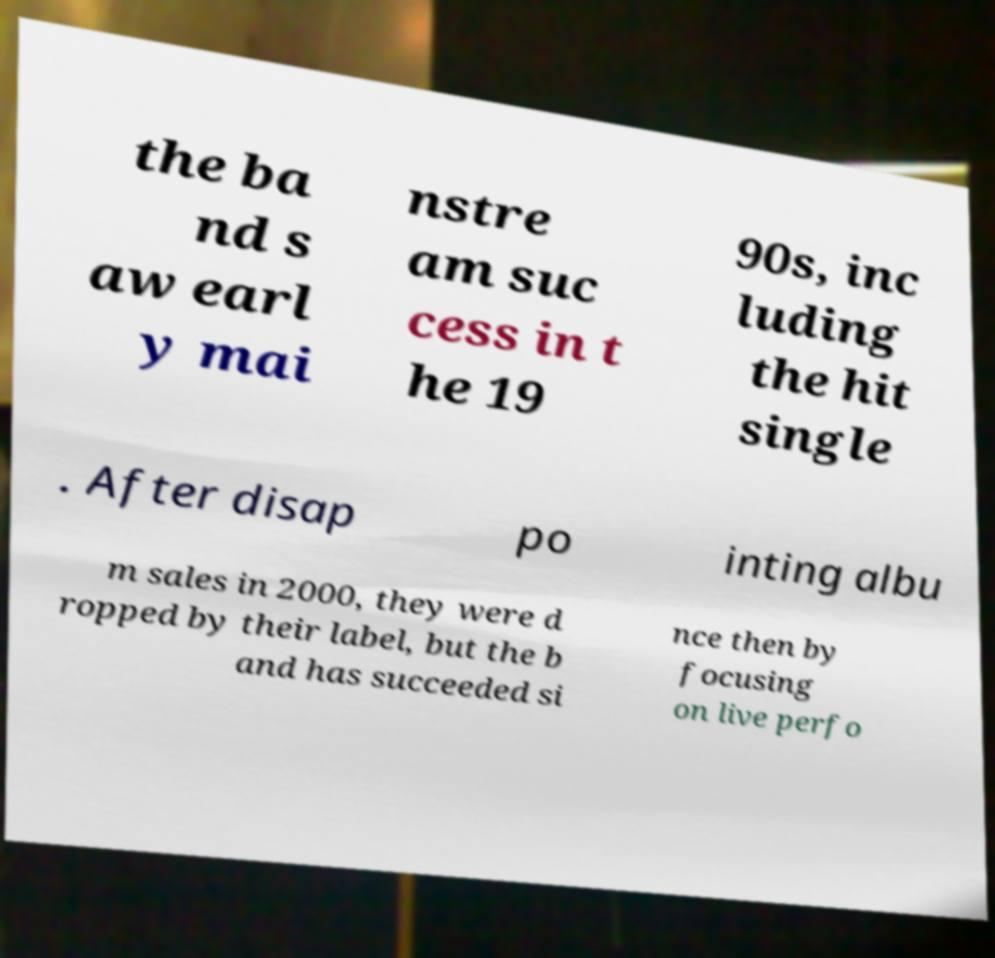For documentation purposes, I need the text within this image transcribed. Could you provide that? the ba nd s aw earl y mai nstre am suc cess in t he 19 90s, inc luding the hit single . After disap po inting albu m sales in 2000, they were d ropped by their label, but the b and has succeeded si nce then by focusing on live perfo 